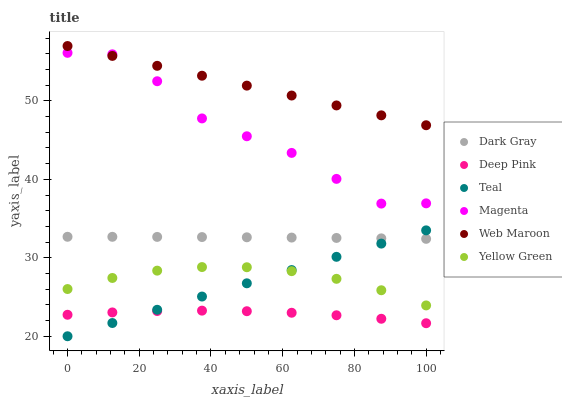Does Deep Pink have the minimum area under the curve?
Answer yes or no. Yes. Does Web Maroon have the maximum area under the curve?
Answer yes or no. Yes. Does Yellow Green have the minimum area under the curve?
Answer yes or no. No. Does Yellow Green have the maximum area under the curve?
Answer yes or no. No. Is Web Maroon the smoothest?
Answer yes or no. Yes. Is Magenta the roughest?
Answer yes or no. Yes. Is Yellow Green the smoothest?
Answer yes or no. No. Is Yellow Green the roughest?
Answer yes or no. No. Does Teal have the lowest value?
Answer yes or no. Yes. Does Yellow Green have the lowest value?
Answer yes or no. No. Does Web Maroon have the highest value?
Answer yes or no. Yes. Does Yellow Green have the highest value?
Answer yes or no. No. Is Dark Gray less than Web Maroon?
Answer yes or no. Yes. Is Web Maroon greater than Yellow Green?
Answer yes or no. Yes. Does Teal intersect Yellow Green?
Answer yes or no. Yes. Is Teal less than Yellow Green?
Answer yes or no. No. Is Teal greater than Yellow Green?
Answer yes or no. No. Does Dark Gray intersect Web Maroon?
Answer yes or no. No. 